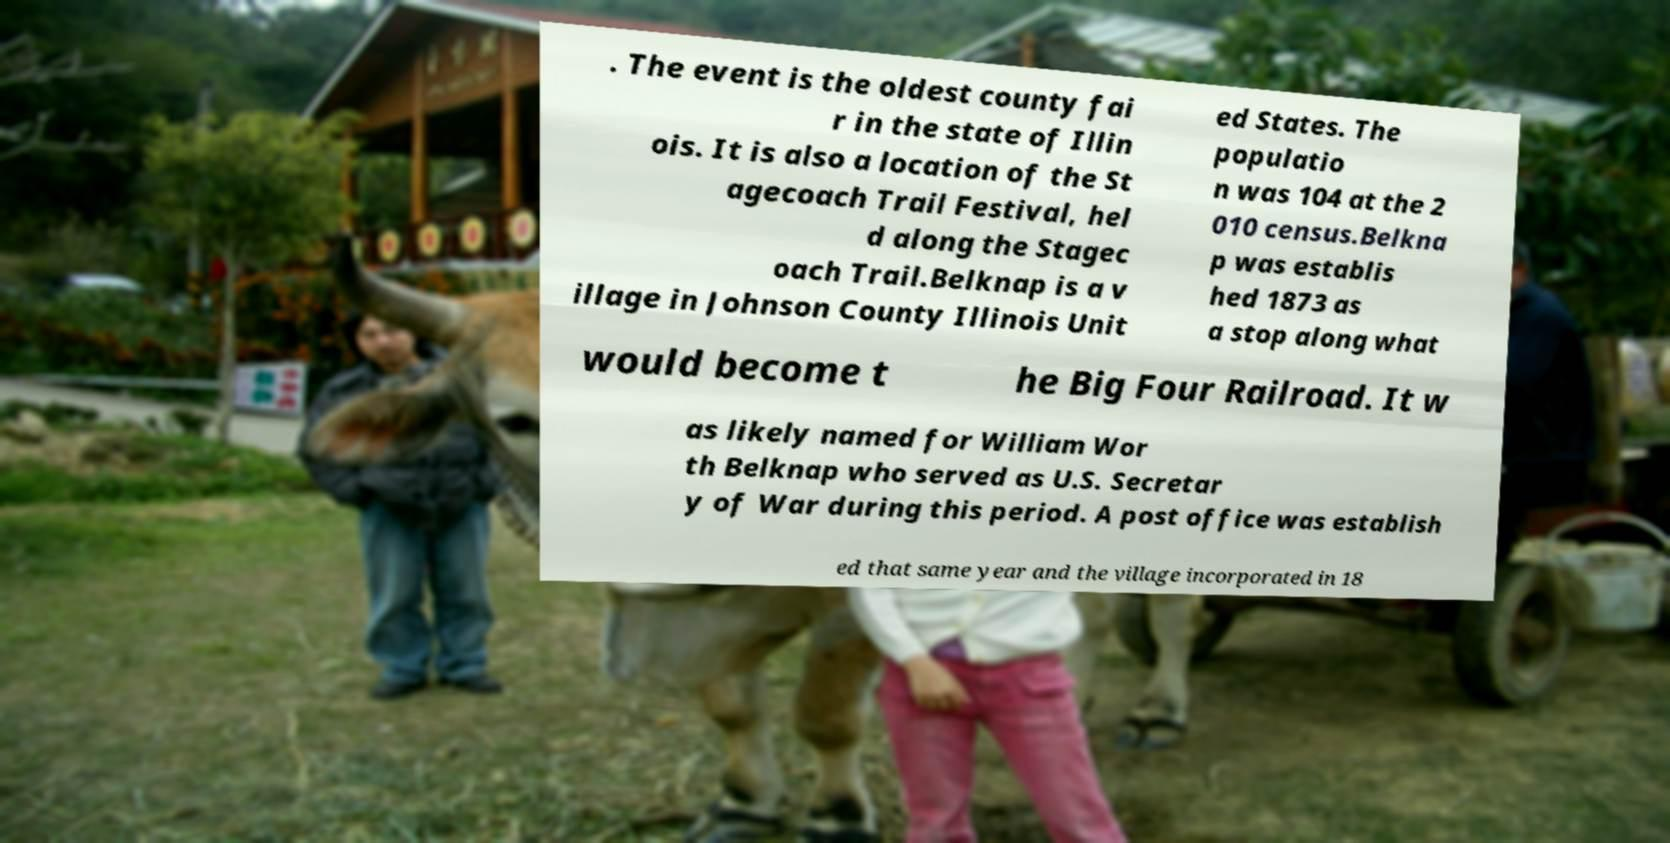I need the written content from this picture converted into text. Can you do that? . The event is the oldest county fai r in the state of Illin ois. It is also a location of the St agecoach Trail Festival, hel d along the Stagec oach Trail.Belknap is a v illage in Johnson County Illinois Unit ed States. The populatio n was 104 at the 2 010 census.Belkna p was establis hed 1873 as a stop along what would become t he Big Four Railroad. It w as likely named for William Wor th Belknap who served as U.S. Secretar y of War during this period. A post office was establish ed that same year and the village incorporated in 18 